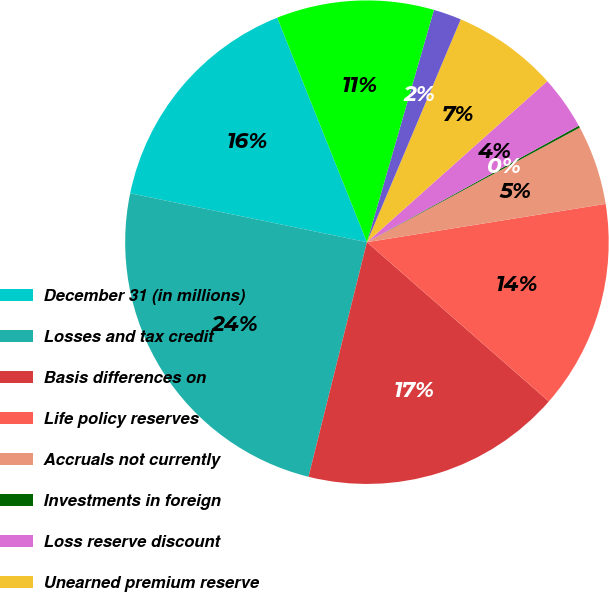Convert chart to OTSL. <chart><loc_0><loc_0><loc_500><loc_500><pie_chart><fcel>December 31 (in millions)<fcel>Losses and tax credit<fcel>Basis differences on<fcel>Life policy reserves<fcel>Accruals not currently<fcel>Investments in foreign<fcel>Loss reserve discount<fcel>Unearned premium reserve<fcel>Fixed assets and intangible<fcel>Other<nl><fcel>15.71%<fcel>24.36%<fcel>17.44%<fcel>13.98%<fcel>5.33%<fcel>0.14%<fcel>3.6%<fcel>7.06%<fcel>1.87%<fcel>10.52%<nl></chart> 